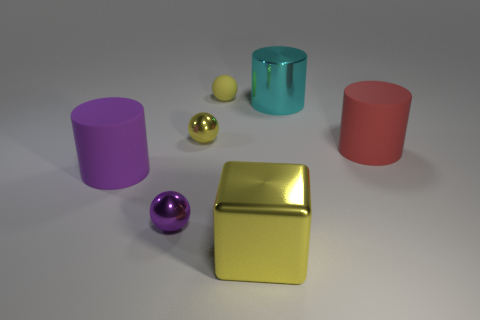Subtract all shiny cylinders. How many cylinders are left? 2 Subtract all cyan cylinders. How many cylinders are left? 2 Add 1 big yellow cylinders. How many big yellow cylinders exist? 1 Add 3 big purple matte objects. How many objects exist? 10 Subtract 0 gray cubes. How many objects are left? 7 Subtract all cubes. How many objects are left? 6 Subtract 1 balls. How many balls are left? 2 Subtract all gray cylinders. Subtract all yellow cubes. How many cylinders are left? 3 Subtract all blue cubes. How many purple balls are left? 1 Subtract all balls. Subtract all large matte objects. How many objects are left? 2 